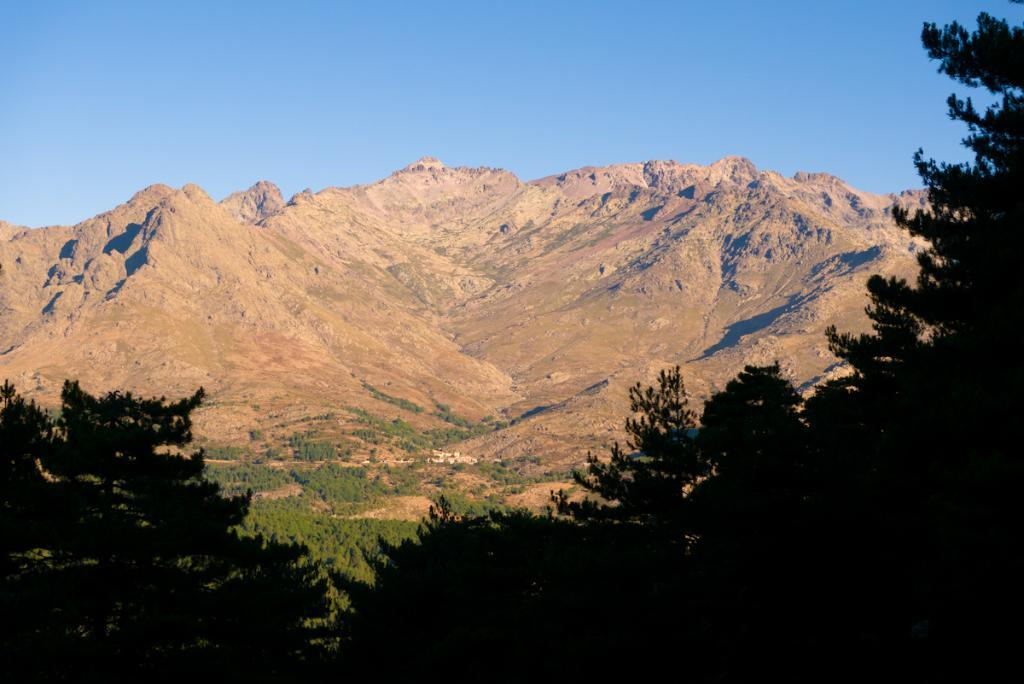What type of vegetation can be seen at the bottom and on the right side of the image? There are trees at the bottom and on the right side of the image. Can you describe the background of the image? There are trees and mountains in the background of the image, along with the sky. What type of muscle can be seen flexing in the image? There is no muscle present in the image; it features trees, mountains, and the sky. What type of yam is being used as a prop in the image? There is no yam present in the image. 